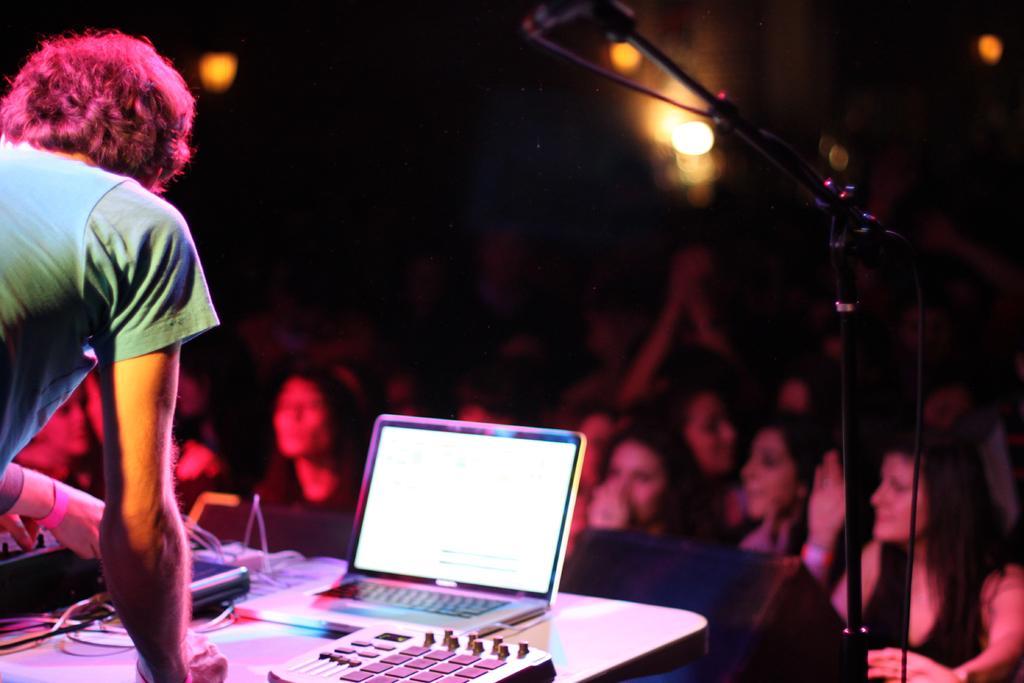How would you summarize this image in a sentence or two? In this image we can see few people and a person is standing, in front of the person there is a table, there is a laptop and few objects on the table, beside the table there is a mic. 